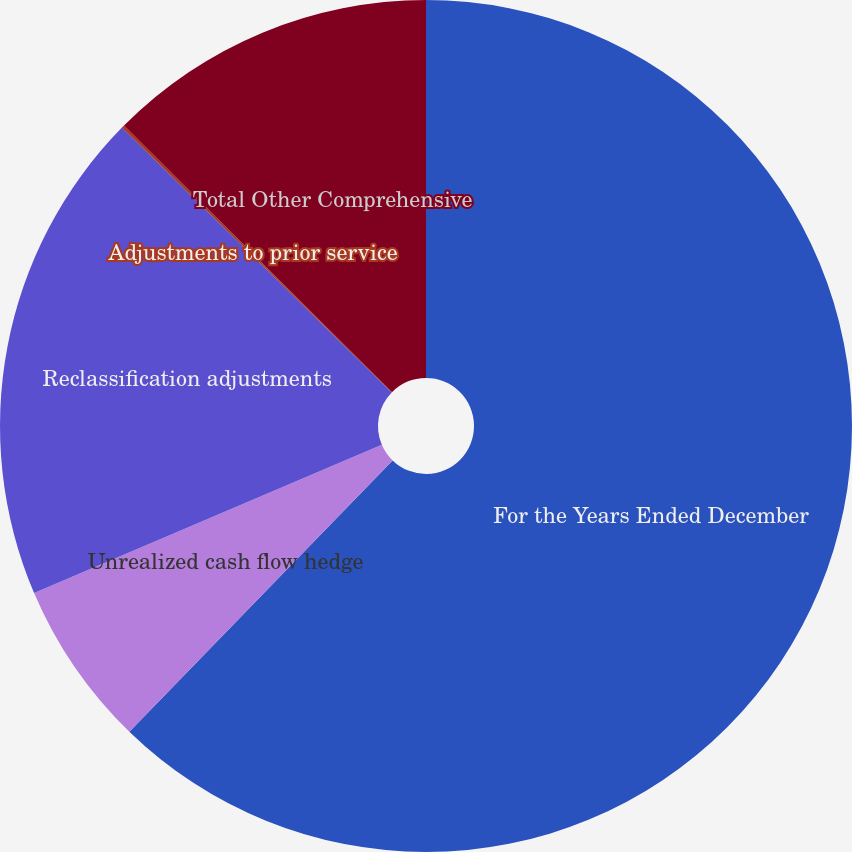Convert chart. <chart><loc_0><loc_0><loc_500><loc_500><pie_chart><fcel>For the Years Ended December<fcel>Unrealized cash flow hedge<fcel>Reclassification adjustments<fcel>Adjustments to prior service<fcel>Total Other Comprehensive<nl><fcel>62.26%<fcel>6.33%<fcel>18.76%<fcel>0.11%<fcel>12.54%<nl></chart> 